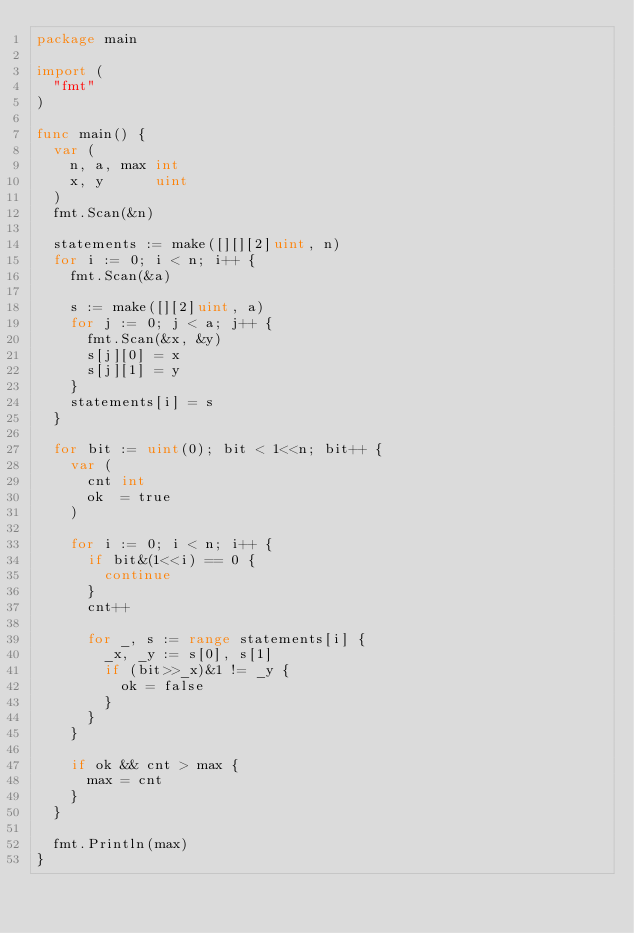Convert code to text. <code><loc_0><loc_0><loc_500><loc_500><_Go_>package main

import (
	"fmt"
)

func main() {
	var (
		n, a, max int
		x, y      uint
	)
	fmt.Scan(&n)

	statements := make([][][2]uint, n)
	for i := 0; i < n; i++ {
		fmt.Scan(&a)

		s := make([][2]uint, a)
		for j := 0; j < a; j++ {
			fmt.Scan(&x, &y)
			s[j][0] = x
			s[j][1] = y
		}
		statements[i] = s
	}

	for bit := uint(0); bit < 1<<n; bit++ {
		var (
			cnt int
			ok  = true
		)

		for i := 0; i < n; i++ {
			if bit&(1<<i) == 0 {
				continue
			}
			cnt++

			for _, s := range statements[i] {
				_x, _y := s[0], s[1]
				if (bit>>_x)&1 != _y {
					ok = false
				}
			}
		}

		if ok && cnt > max {
			max = cnt
		}
	}

	fmt.Println(max)
}
</code> 